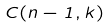<formula> <loc_0><loc_0><loc_500><loc_500>C ( n - 1 , k )</formula> 